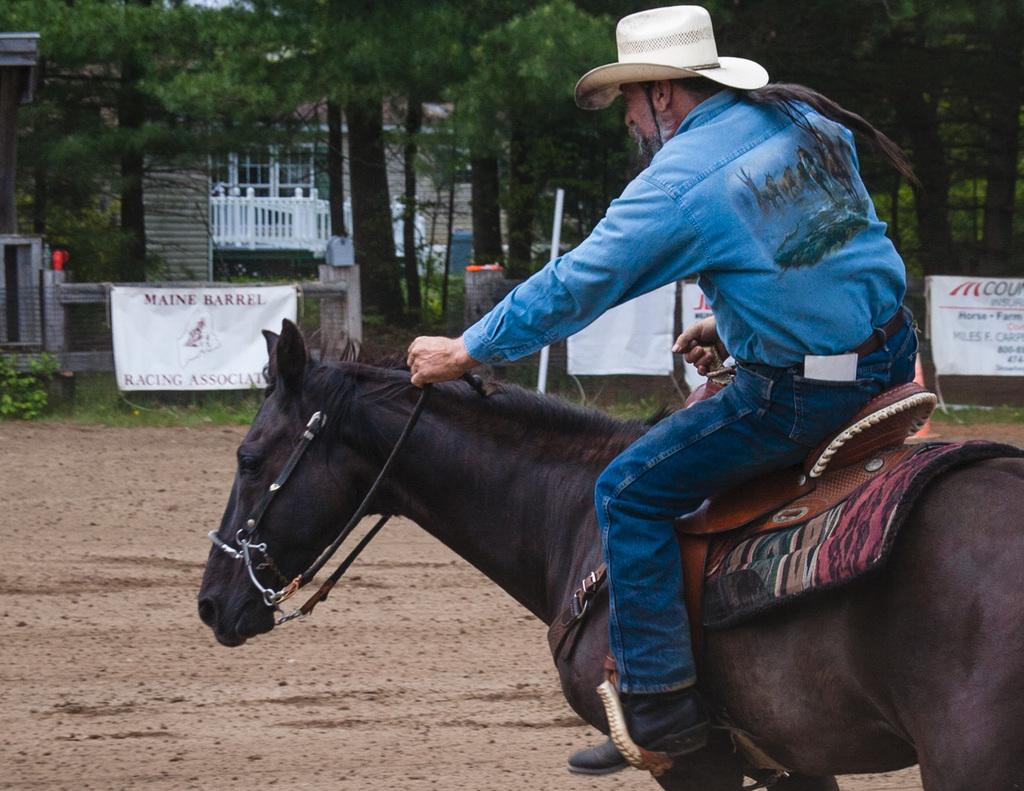What is the man in the image doing? The man is riding a horse in the image. What else can be seen in the image besides the man and the horse? There are banners and trees visible in the image. What is in the background of the image? There is a building with windows in the background of the image. Can you see a wave crashing on the shore in the image? There is no wave or shore present in the image. 